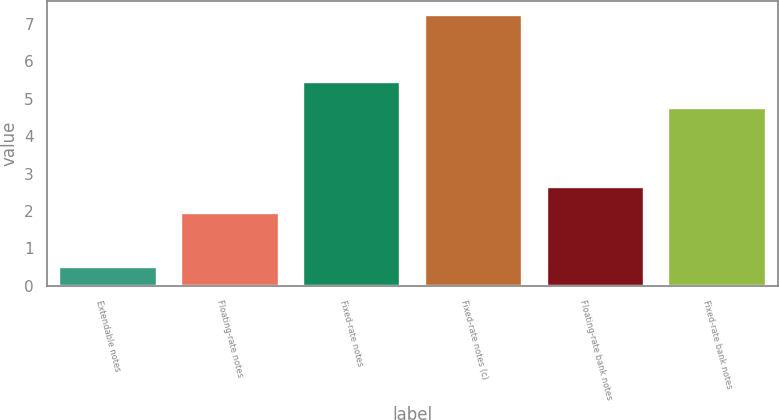Convert chart to OTSL. <chart><loc_0><loc_0><loc_500><loc_500><bar_chart><fcel>Extendable notes<fcel>Floating-rate notes<fcel>Fixed-rate notes<fcel>Fixed-rate notes (c)<fcel>Floating-rate bank notes<fcel>Fixed-rate bank notes<nl><fcel>0.49<fcel>1.95<fcel>5.45<fcel>7.25<fcel>2.63<fcel>4.75<nl></chart> 